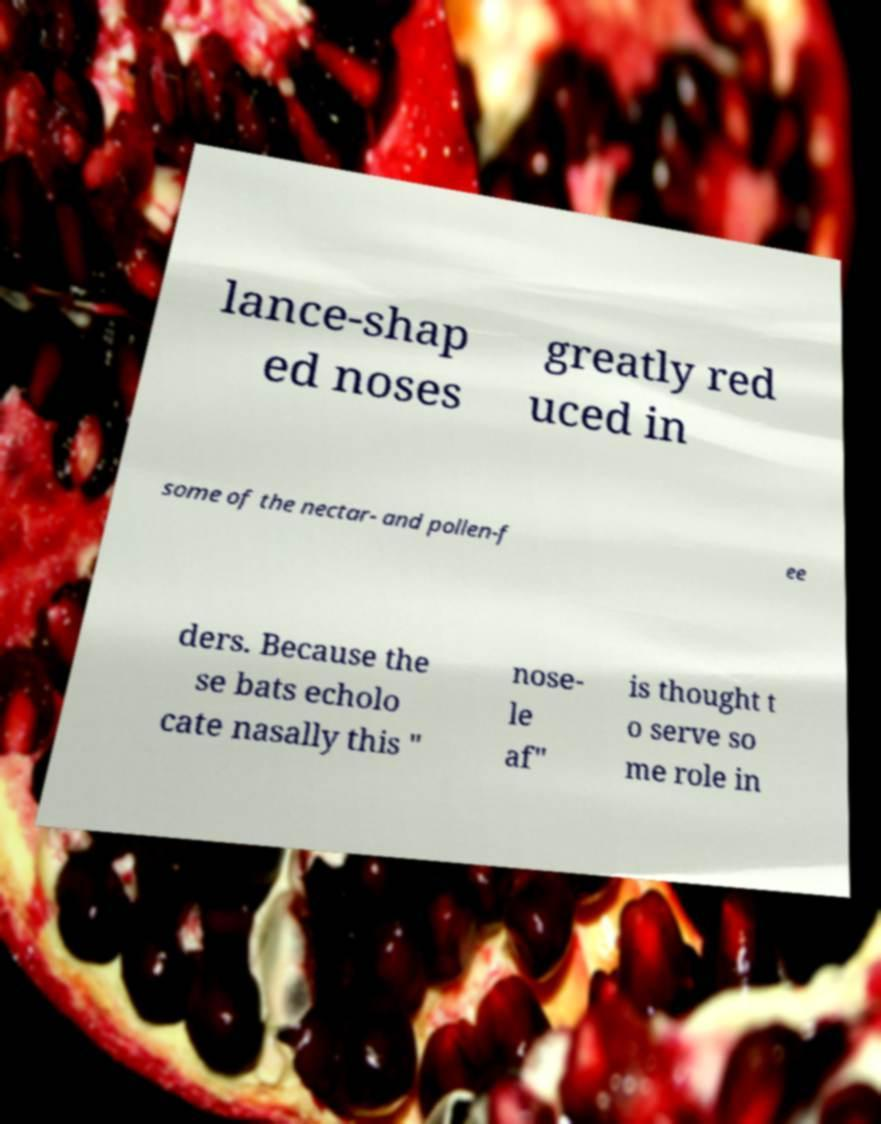Can you accurately transcribe the text from the provided image for me? lance-shap ed noses greatly red uced in some of the nectar- and pollen-f ee ders. Because the se bats echolo cate nasally this " nose- le af" is thought t o serve so me role in 